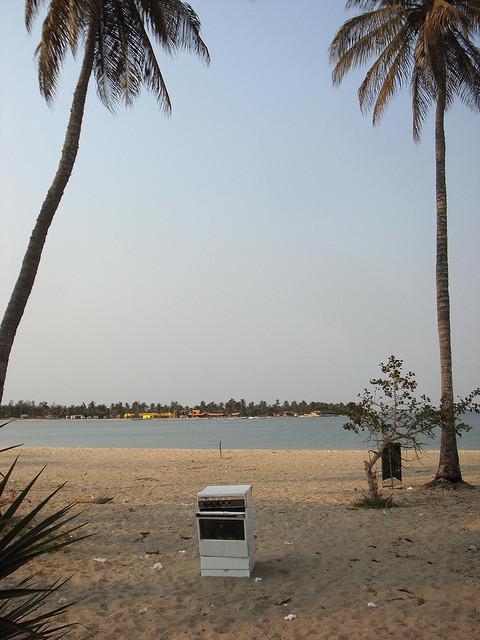How many people are wearing a red shirt?
Give a very brief answer. 0. 